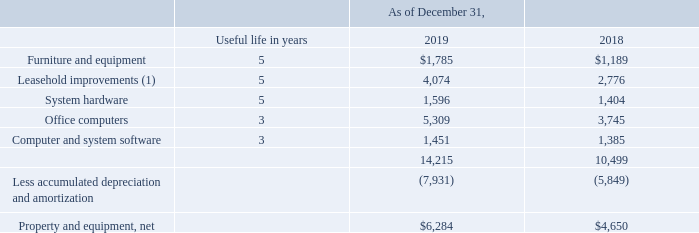Property and equipment consist of the following (in thousands):
(1) Lesser of the lease term or the estimated useful lives of the improvements, which generally may be up to 5 years.
Depreciation and amortization expense for the years ended December 31, 2019, 2018 and 2017 was $2.2 million, $1.8 million and $1.9 million, respectively.
What was the Depreciation and amortization expense for the years ended December 31, 2019? $2.2 million. What was the Depreciation and amortization expense for the years ended December 31, 2018? $1.8 million. What was the Depreciation and amortization expense for the years ended December 31, 2017? $1.9 million. What is the change in Furniture and equipment from December 31, 2019 to December 31, 2018?
Answer scale should be: thousand. 1,785-1,189
Answer: 596. What is the change in Leasehold improvements from December 31, 2019 to December 31, 2018?
Answer scale should be: thousand. 4,074-2,776
Answer: 1298. What is the change in System hardware from December 31, 2019 to December 31, 2018?
Answer scale should be: thousand. 1,596-1,404
Answer: 192. 